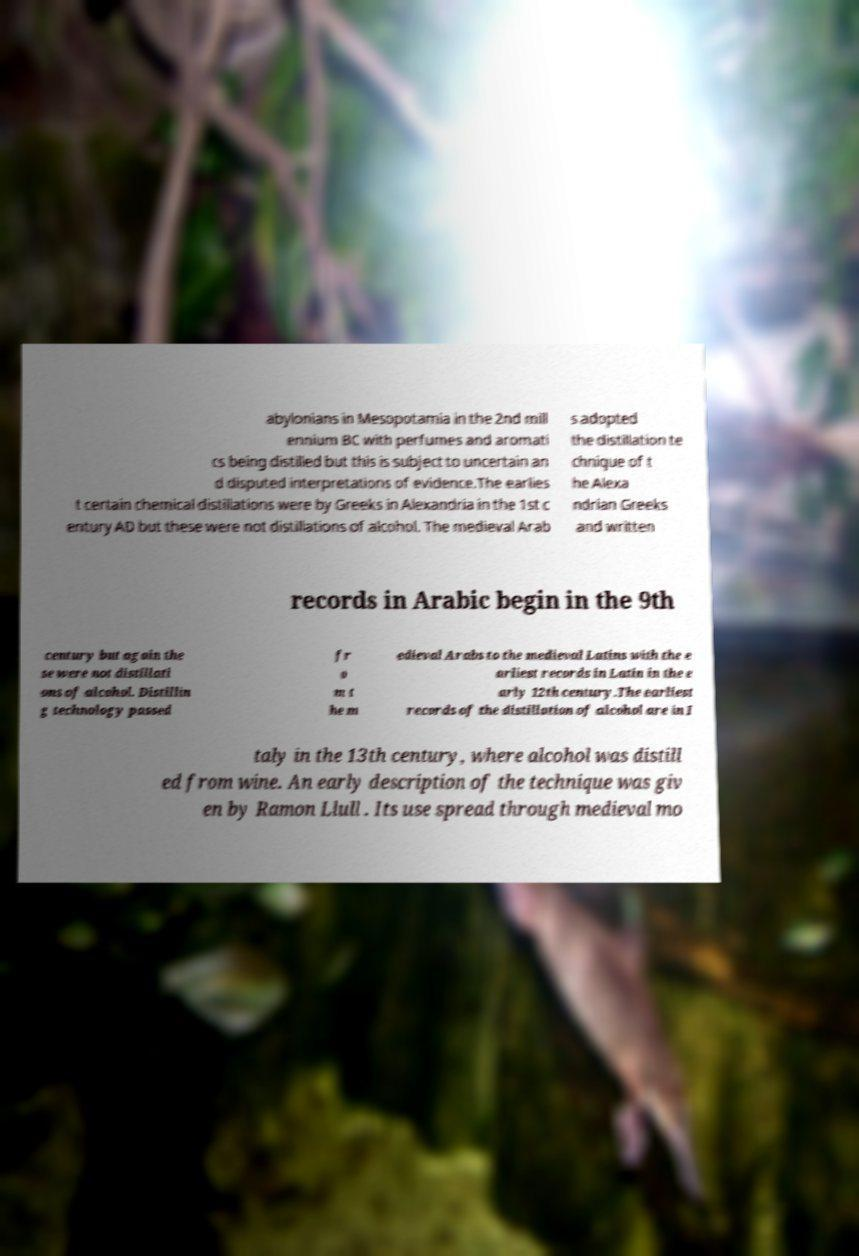Please identify and transcribe the text found in this image. abylonians in Mesopotamia in the 2nd mill ennium BC with perfumes and aromati cs being distilled but this is subject to uncertain an d disputed interpretations of evidence.The earlies t certain chemical distillations were by Greeks in Alexandria in the 1st c entury AD but these were not distillations of alcohol. The medieval Arab s adopted the distillation te chnique of t he Alexa ndrian Greeks and written records in Arabic begin in the 9th century but again the se were not distillati ons of alcohol. Distillin g technology passed fr o m t he m edieval Arabs to the medieval Latins with the e arliest records in Latin in the e arly 12th century.The earliest records of the distillation of alcohol are in I taly in the 13th century, where alcohol was distill ed from wine. An early description of the technique was giv en by Ramon Llull . Its use spread through medieval mo 